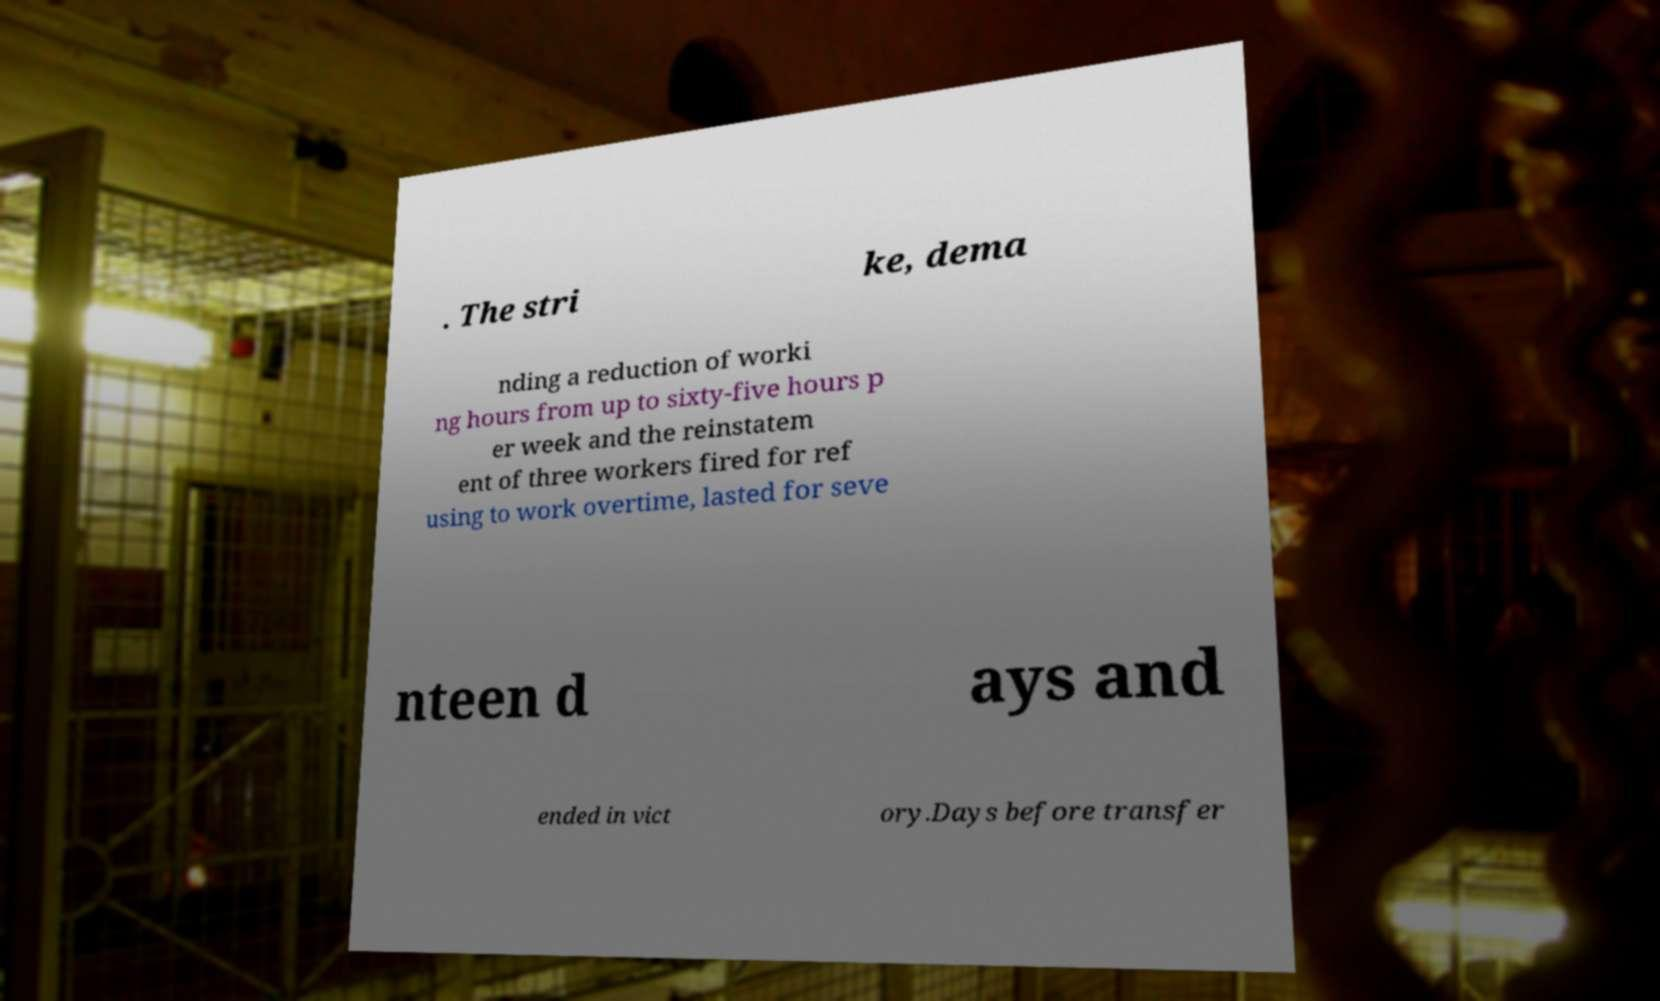I need the written content from this picture converted into text. Can you do that? . The stri ke, dema nding a reduction of worki ng hours from up to sixty-five hours p er week and the reinstatem ent of three workers fired for ref using to work overtime, lasted for seve nteen d ays and ended in vict ory.Days before transfer 